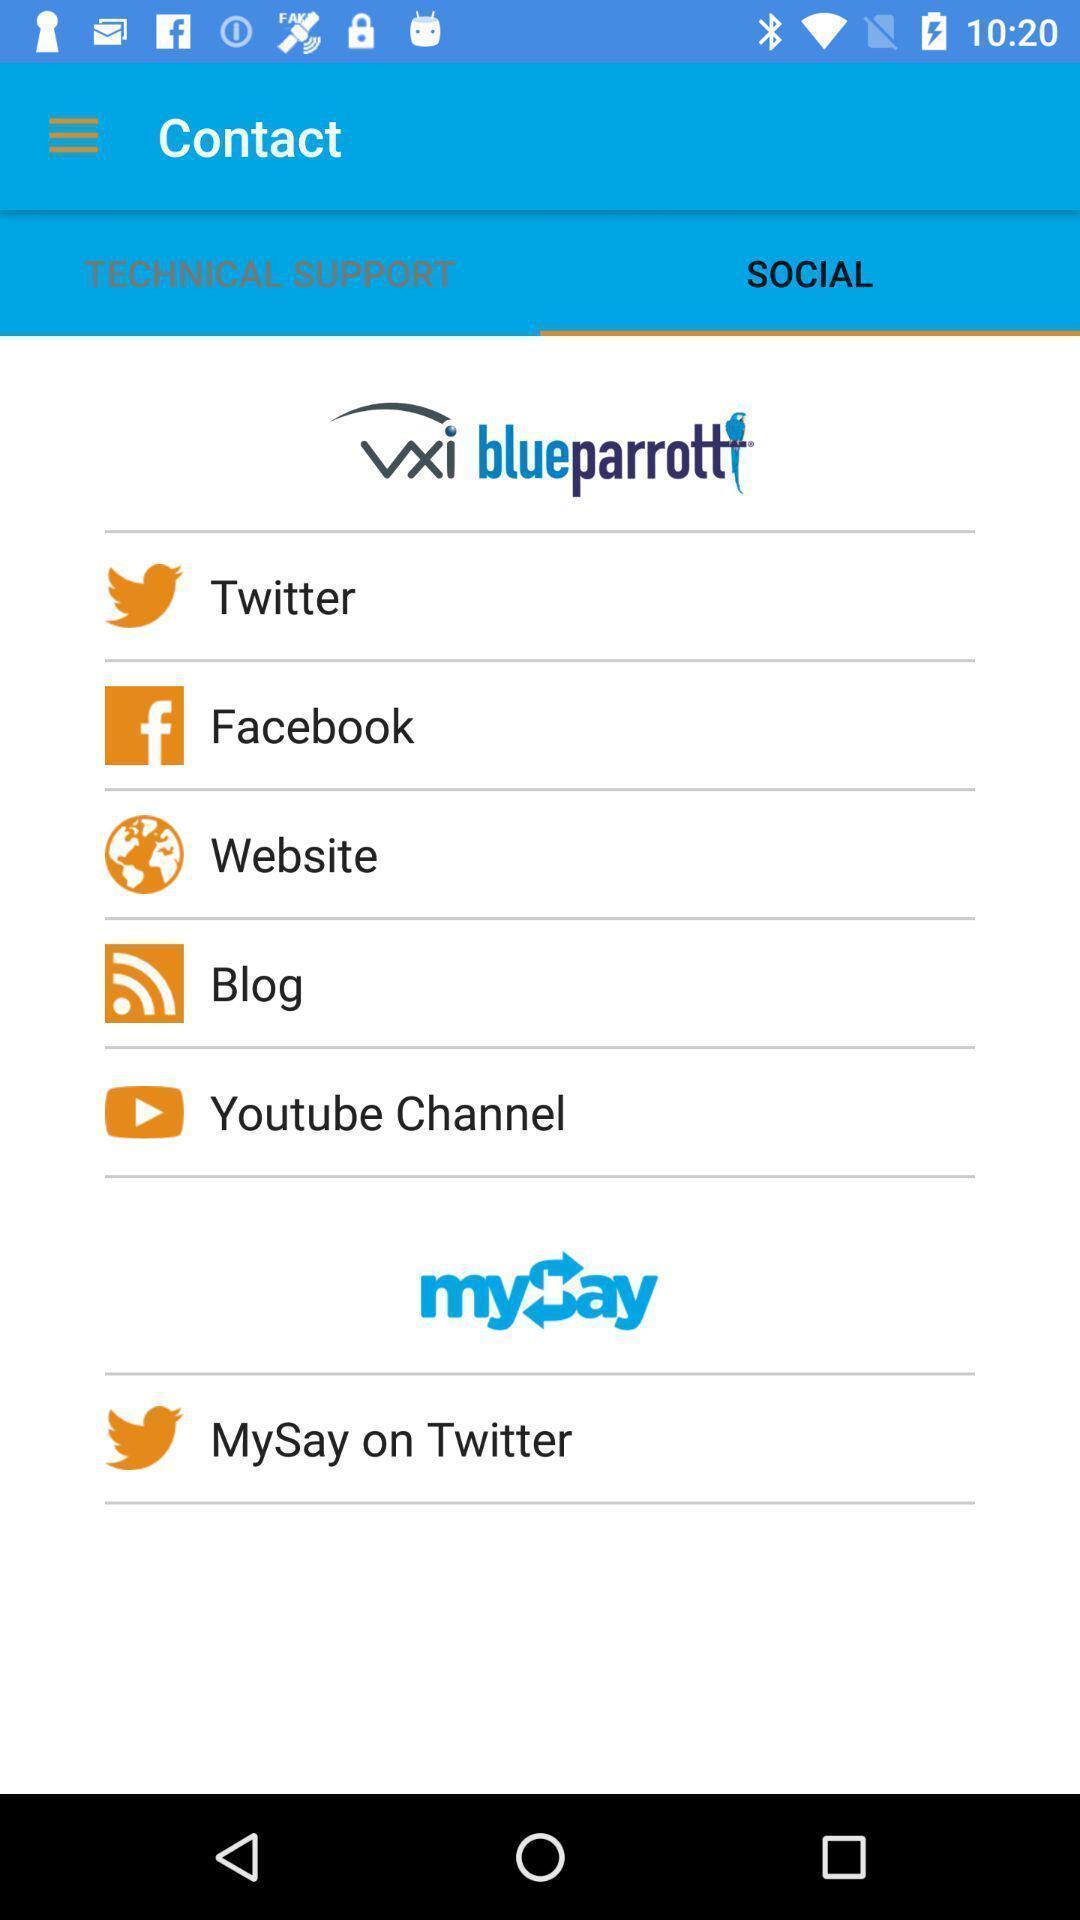Tell me what you see in this picture. Page displaying with list of different application options. 